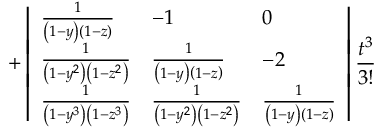<formula> <loc_0><loc_0><loc_500><loc_500>+ \left | \begin{array} { l l l } { \frac { 1 } { \left ( 1 - y \right ) \left ( 1 - z \right ) } } & { - 1 } & { 0 } \\ { \frac { 1 } { \left ( 1 - y ^ { 2 } \right ) \left ( 1 - z ^ { 2 } \right ) } } & { \frac { 1 } { \left ( 1 - y \right ) \left ( 1 - z \right ) } } & { - 2 } \\ { \frac { 1 } { \left ( 1 - y ^ { 3 } \right ) \left ( 1 - z ^ { 3 } \right ) } } & { \frac { 1 } { \left ( 1 - y ^ { 2 } \right ) \left ( 1 - z ^ { 2 } \right ) } } & { \frac { 1 } { \left ( 1 - y \right ) \left ( 1 - z \right ) } } \end{array} \right | \frac { t ^ { 3 } } { 3 ! }</formula> 